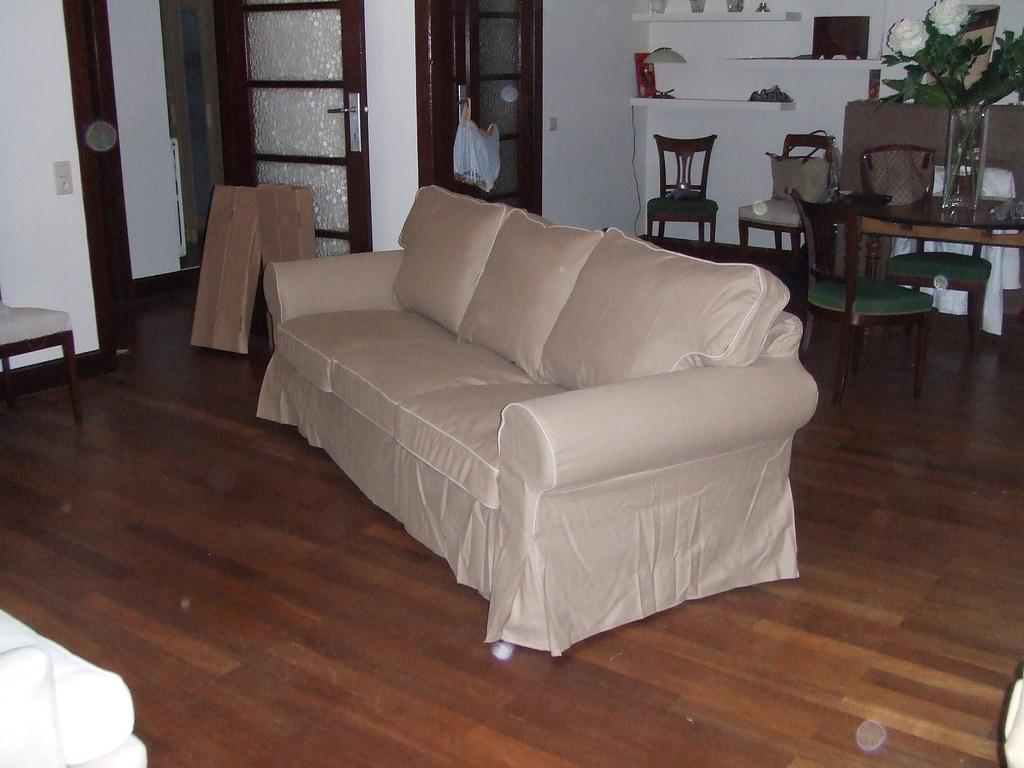What type of furniture is in the image? There is a couch in the image. What can be seen in the background of the image? There is a dining table, a flower pot on a table, a door, and a wall in the background of the image. What type of cast can be seen on the couch in the image? There is no cast present in the image; it only features a couch and other items in the background. 